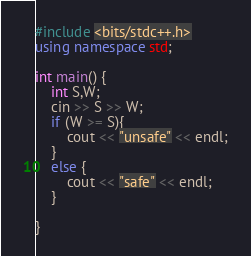Convert code to text. <code><loc_0><loc_0><loc_500><loc_500><_C++_>#include <bits/stdc++.h>
using namespace std;

int main() {
    int S,W;
    cin >> S >> W;
    if (W >= S){
        cout << "unsafe" << endl;
    }
    else {
        cout << "safe" << endl;
    }
    
}</code> 